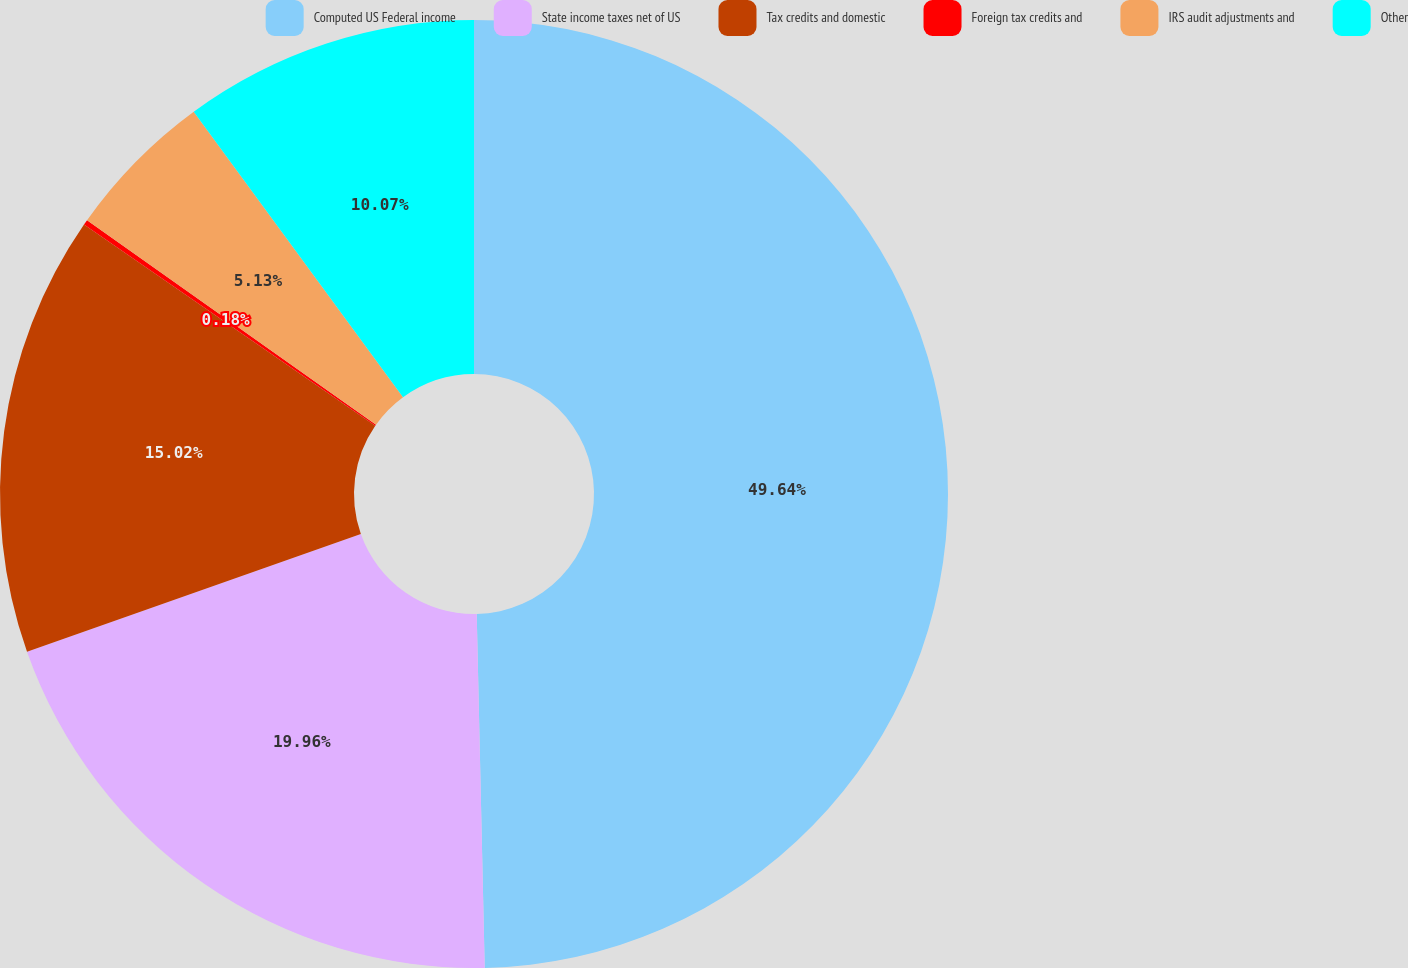Convert chart to OTSL. <chart><loc_0><loc_0><loc_500><loc_500><pie_chart><fcel>Computed US Federal income<fcel>State income taxes net of US<fcel>Tax credits and domestic<fcel>Foreign tax credits and<fcel>IRS audit adjustments and<fcel>Other<nl><fcel>49.64%<fcel>19.96%<fcel>15.02%<fcel>0.18%<fcel>5.13%<fcel>10.07%<nl></chart> 